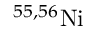<formula> <loc_0><loc_0><loc_500><loc_500>^ { 5 5 , 5 6 } N i</formula> 